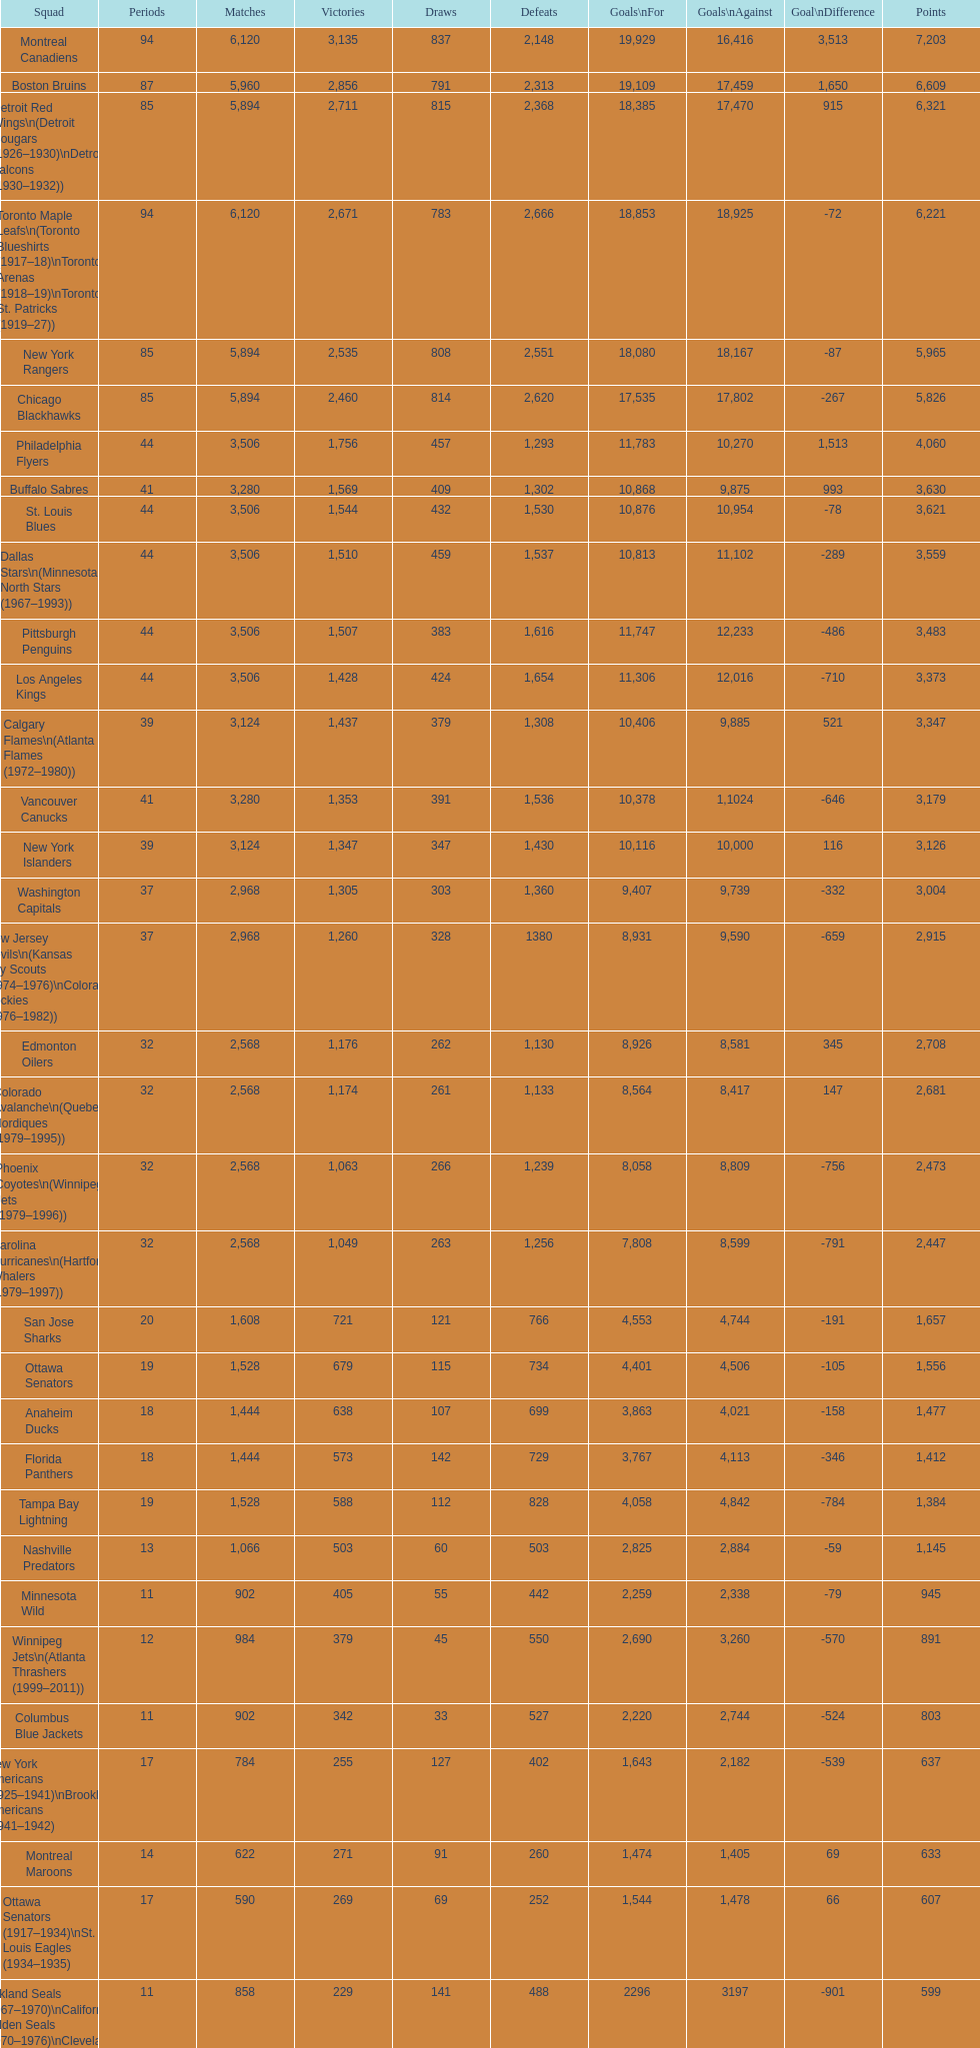Which team was last in terms of points up until this point? Montreal Wanderers. 